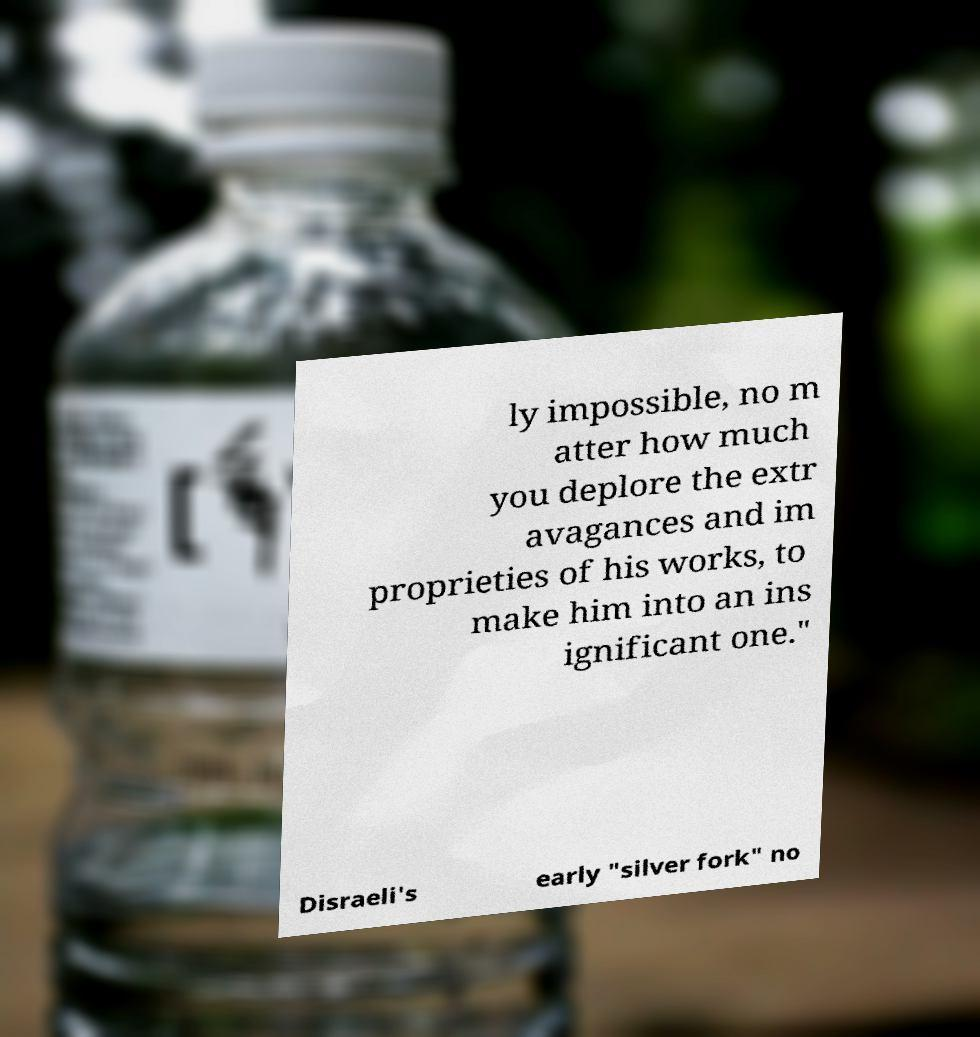There's text embedded in this image that I need extracted. Can you transcribe it verbatim? ly impossible, no m atter how much you deplore the extr avagances and im proprieties of his works, to make him into an ins ignificant one." Disraeli's early "silver fork" no 